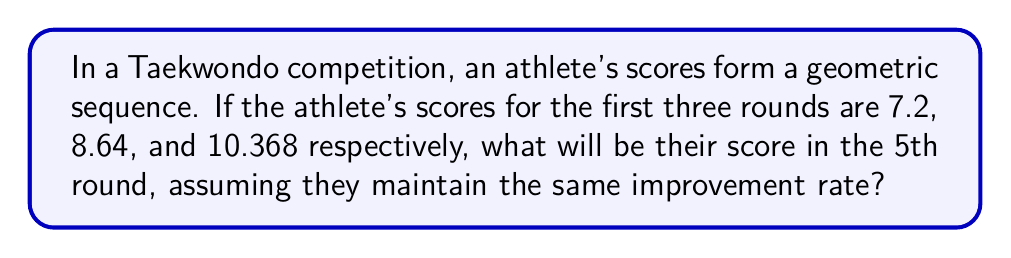Can you answer this question? Let's approach this step-by-step:

1) In a geometric sequence, each term is a constant multiple of the previous term. Let's call this constant $r$.

2) We can find $r$ by dividing any term by the previous term:

   $r = \frac{8.64}{7.2} = \frac{10.368}{8.64} = 1.2$

3) Now we know that each term is 1.2 times the previous term.

4) We can represent the sequence as:

   $a_1 = 7.2$
   $a_2 = 7.2 \cdot 1.2 = 8.64$
   $a_3 = 8.64 \cdot 1.2 = 10.368$
   $a_4 = 10.368 \cdot 1.2 = 12.4416$
   $a_5 = 12.4416 \cdot 1.2 = 14.92992$

5) Alternatively, we could have used the formula for the nth term of a geometric sequence:

   $a_n = a_1 \cdot r^{n-1}$

   Where $a_1 = 7.2$, $r = 1.2$, and we're looking for $n = 5$

   $a_5 = 7.2 \cdot 1.2^{5-1} = 7.2 \cdot 1.2^4 = 7.2 \cdot 2.0736 = 14.92992$

6) Therefore, the athlete's score in the 5th round would be 14.92992.
Answer: 14.92992 